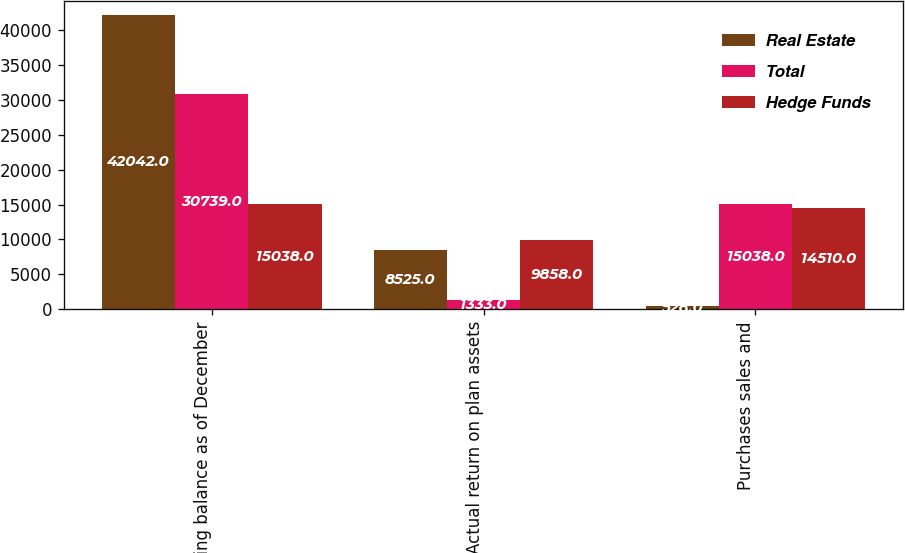Convert chart. <chart><loc_0><loc_0><loc_500><loc_500><stacked_bar_chart><ecel><fcel>Ending balance as of December<fcel>Actual return on plan assets<fcel>Purchases sales and<nl><fcel>Real Estate<fcel>42042<fcel>8525<fcel>528<nl><fcel>Total<fcel>30739<fcel>1333<fcel>15038<nl><fcel>Hedge Funds<fcel>15038<fcel>9858<fcel>14510<nl></chart> 